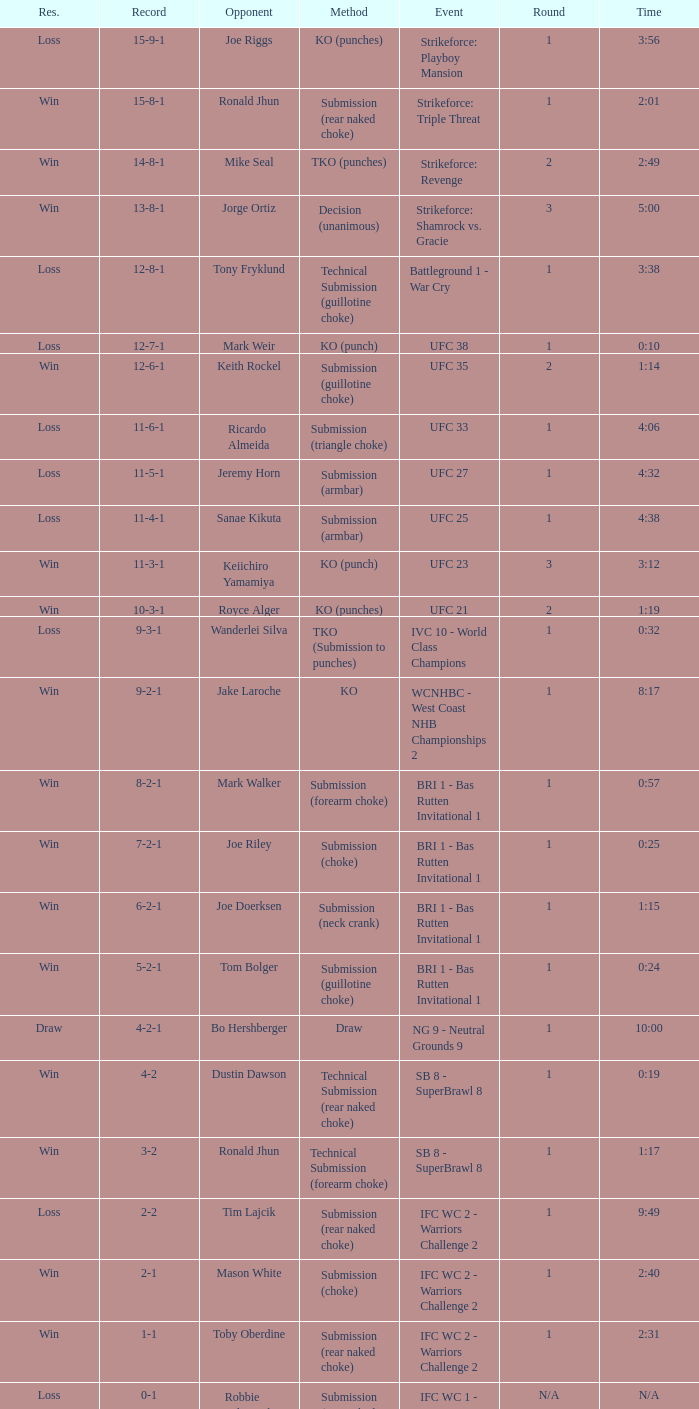In the 10-second long fight, who was the contender? Mark Weir. 